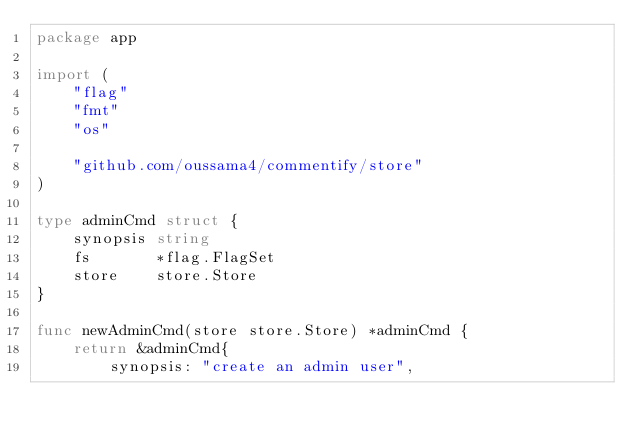Convert code to text. <code><loc_0><loc_0><loc_500><loc_500><_Go_>package app

import (
	"flag"
	"fmt"
	"os"

	"github.com/oussama4/commentify/store"
)

type adminCmd struct {
	synopsis string
	fs       *flag.FlagSet
	store    store.Store
}

func newAdminCmd(store store.Store) *adminCmd {
	return &adminCmd{
		synopsis: "create an admin user",</code> 